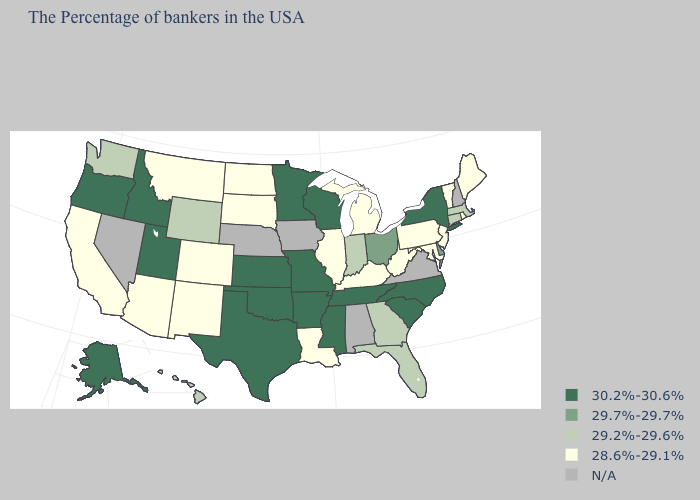What is the value of Arizona?
Short answer required. 28.6%-29.1%. What is the value of Oregon?
Answer briefly. 30.2%-30.6%. Among the states that border West Virginia , which have the lowest value?
Write a very short answer. Maryland, Pennsylvania, Kentucky. Is the legend a continuous bar?
Write a very short answer. No. Among the states that border Kentucky , does Illinois have the highest value?
Short answer required. No. Does the first symbol in the legend represent the smallest category?
Answer briefly. No. Name the states that have a value in the range 29.7%-29.7%?
Concise answer only. Delaware, Ohio. What is the lowest value in states that border Maryland?
Short answer required. 28.6%-29.1%. Name the states that have a value in the range 29.2%-29.6%?
Concise answer only. Massachusetts, Connecticut, Florida, Georgia, Indiana, Wyoming, Washington, Hawaii. Which states have the lowest value in the West?
Be succinct. Colorado, New Mexico, Montana, Arizona, California. Among the states that border Utah , does Wyoming have the lowest value?
Keep it brief. No. Among the states that border Wyoming , does South Dakota have the highest value?
Write a very short answer. No. What is the value of North Carolina?
Answer briefly. 30.2%-30.6%. What is the value of Missouri?
Give a very brief answer. 30.2%-30.6%. How many symbols are there in the legend?
Short answer required. 5. 